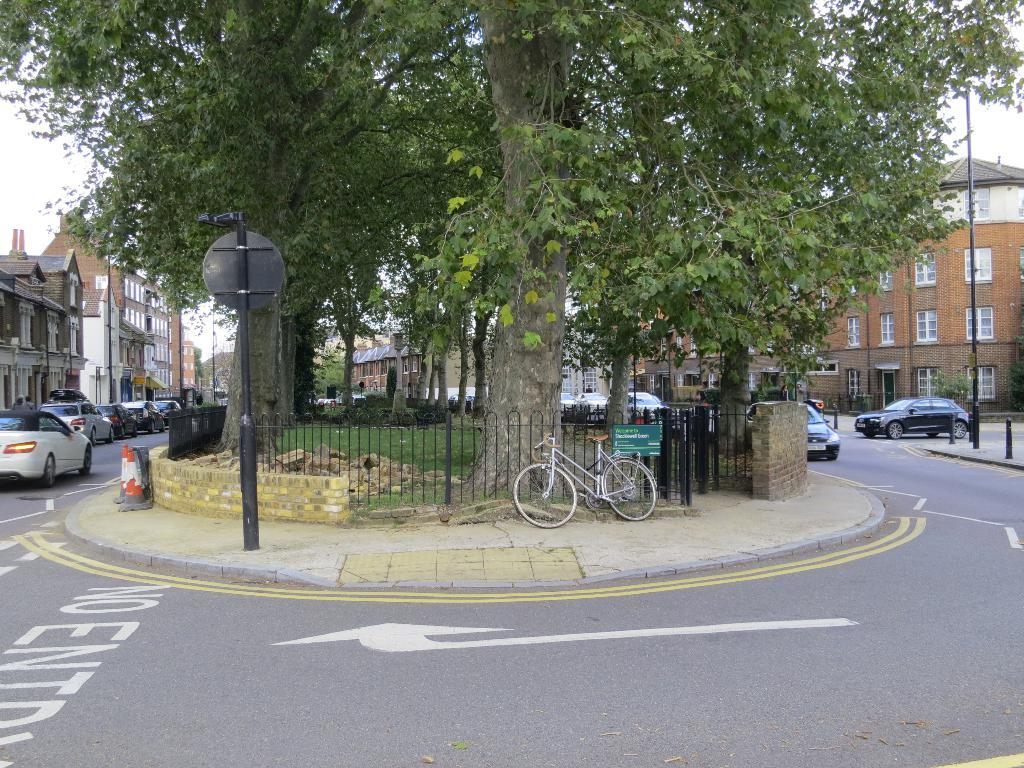What types of vehicles can be seen in the image? There are vehicles in the image, but the specific types are not mentioned. What mode of transportation is also present in the image? There is a bicycle in the image. What natural elements are visible in the image? Plants, trees, and grass are visible in the image. What man-made structures can be seen in the image? There are iron grills, poles, buildings, and cone barricades in the image. What is visible in the background of the image? The sky is visible in the background of the image. What type of learning can be observed in the image? There is no indication of learning or educational activities in the image. How does the brake system work on the bicycle in the image? The image does not show the bicycle's brake system or provide any information about its functionality. 